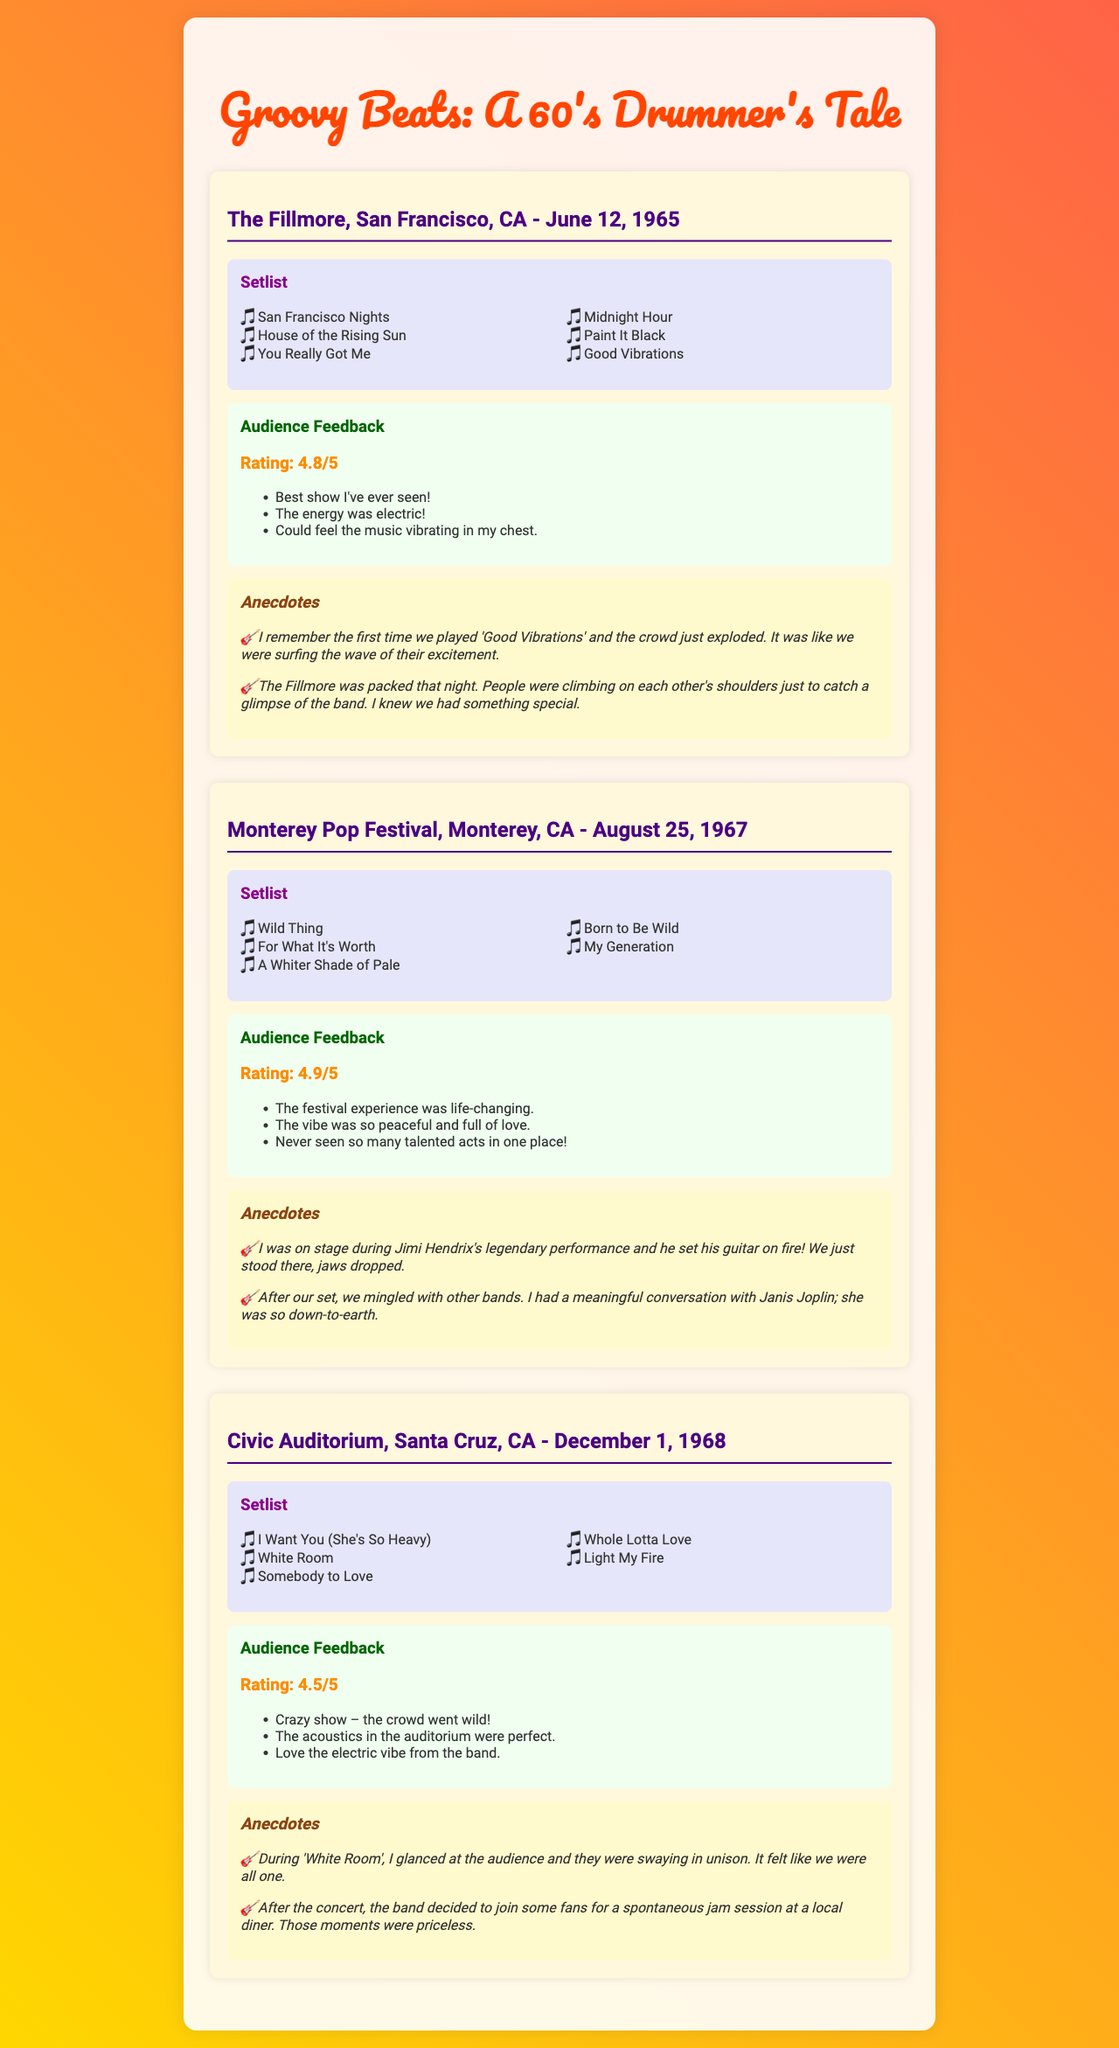What was the rating for the Fillmore concert? The document lists the audience feedback rating for the Fillmore concert as 4.8 out of 5.
Answer: 4.8/5 What is the title of the first song in the Monterey Pop Festival setlist? The first song listed in the Monterey Pop Festival setlist is "Wild Thing."
Answer: Wild Thing How many songs were performed at the Civic Auditorium concert? The Civic Auditorium setlist contains five songs in total.
Answer: Five What memorable incident happened during Jimi Hendrix's performance? According to the document, Jimi Hendrix set his guitar on fire during his legendary performance.
Answer: Set his guitar on fire Which concert received the highest audience feedback rating? The Monterey Pop Festival concert received the highest audience feedback rating of 4.9 out of 5.
Answer: 4.9/5 What was the venue for the concert on June 12, 1965? The concert on June 12, 1965, took place at The Fillmore in San Francisco, CA.
Answer: The Fillmore What was the atmosphere described in the feedback for the Monterey Pop Festival? The feedback describes the atmosphere at the Monterey Pop Festival as peaceful and full of love.
Answer: Peaceful and full of love What spontaneous activity did the band do after the concert at Civic Auditorium? After the Civic Auditorium concert, the band joined fans for a spontaneous jam session at a local diner.
Answer: Spontaneous jam session at a local diner 